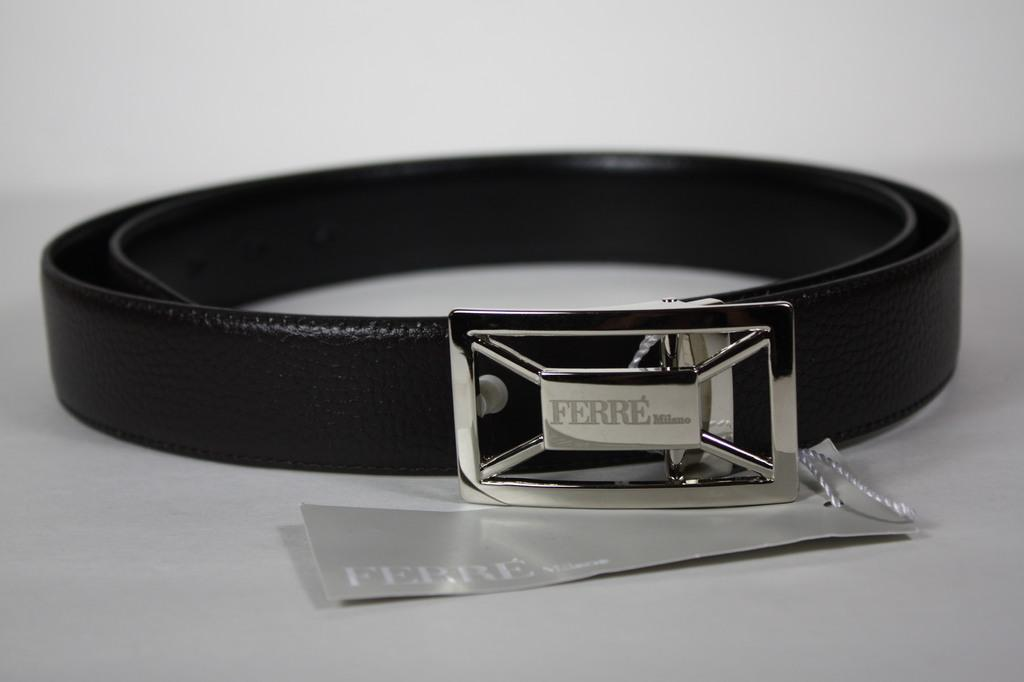What type of accessory is present in the image? There is a belt in the image. What other object can be seen in the image? There is a metal object with text written on it in the image. What type of fiction is the belt reading in the image? There is no indication that the belt is reading any fiction, as belts are inanimate objects and cannot read. 